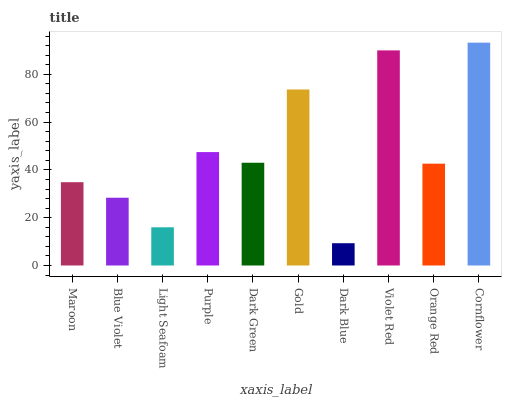Is Dark Blue the minimum?
Answer yes or no. Yes. Is Cornflower the maximum?
Answer yes or no. Yes. Is Blue Violet the minimum?
Answer yes or no. No. Is Blue Violet the maximum?
Answer yes or no. No. Is Maroon greater than Blue Violet?
Answer yes or no. Yes. Is Blue Violet less than Maroon?
Answer yes or no. Yes. Is Blue Violet greater than Maroon?
Answer yes or no. No. Is Maroon less than Blue Violet?
Answer yes or no. No. Is Dark Green the high median?
Answer yes or no. Yes. Is Orange Red the low median?
Answer yes or no. Yes. Is Cornflower the high median?
Answer yes or no. No. Is Dark Green the low median?
Answer yes or no. No. 